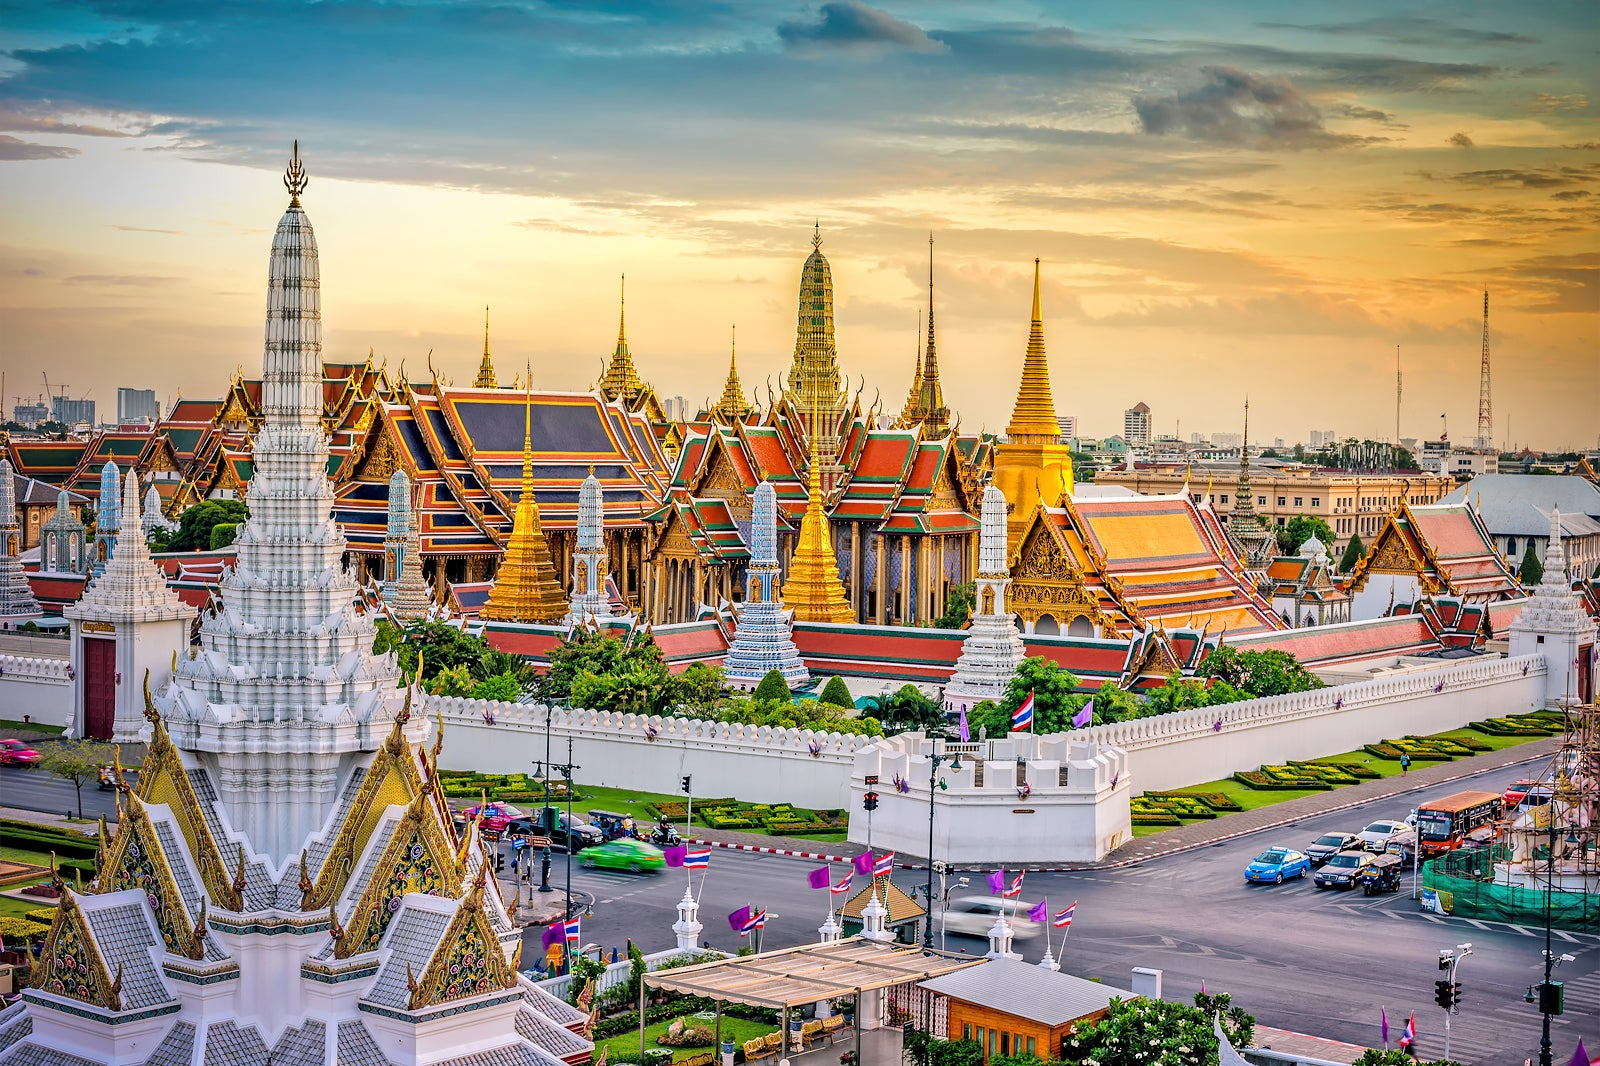What mythical creatures could be imagined guarding the Grand Palace in a fantastical story? In a fantastical story, the Grand Palace could be guarded by an array of mythical creatures inspired by Thai folklore. Majestic Garudas with wings of gold and feathers shimmering in every color of the rainbow might soar above, their eyes vigilant against any threat. At the palace gates, fearsome Naga serpents, with scales that sparkle like gems, could writhe and coil, their multiple heads watching ceaselessly. Guardian giants or Yakshas, with skin in deep hues of green and red and armed with colossal weapons, might stand sentinel along the palace walls, ready to ward off any evil. These mythical protectors would bring an air of mystical wonder and formidable protection to the palace, adding to its already enchanting presence. 